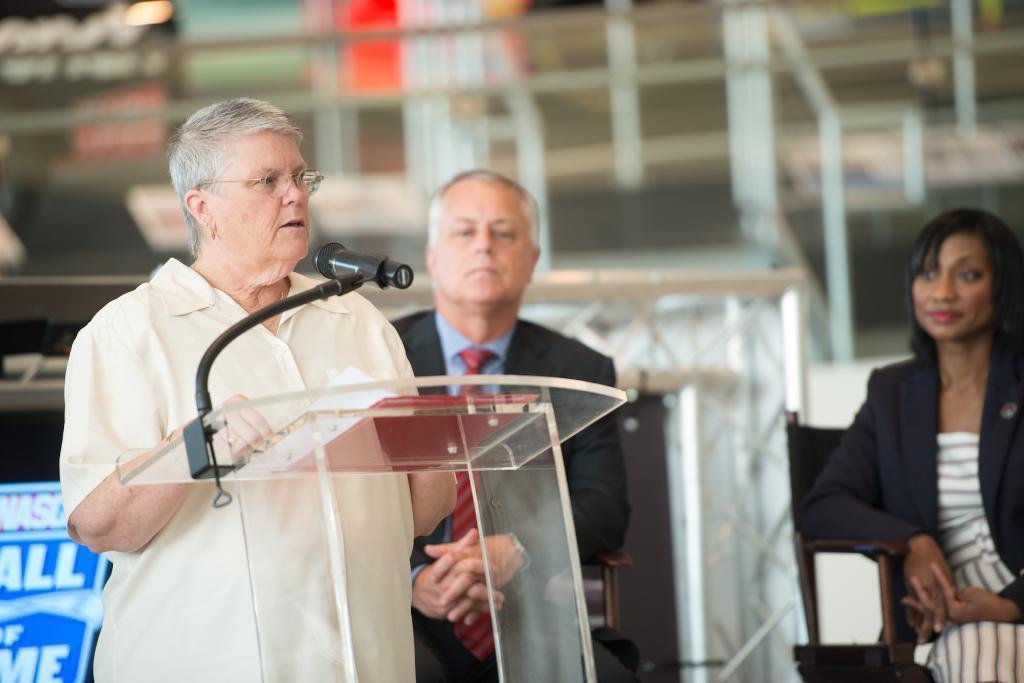Could you give a brief overview of what you see in this image? In the center of the image we can see a man is sitting on a chair and wearing suit, tie. On the left side of the image we can see a man is standing in-front of podium and talking. On podium we can see a boom, mic with stand. On the right side of the image we can see a lady is sitting on a chair and smiling. In the background of the image we can see the rods, boards, light. At the top of the image we can see the roof. In the bottom left corner we can see a banner. 